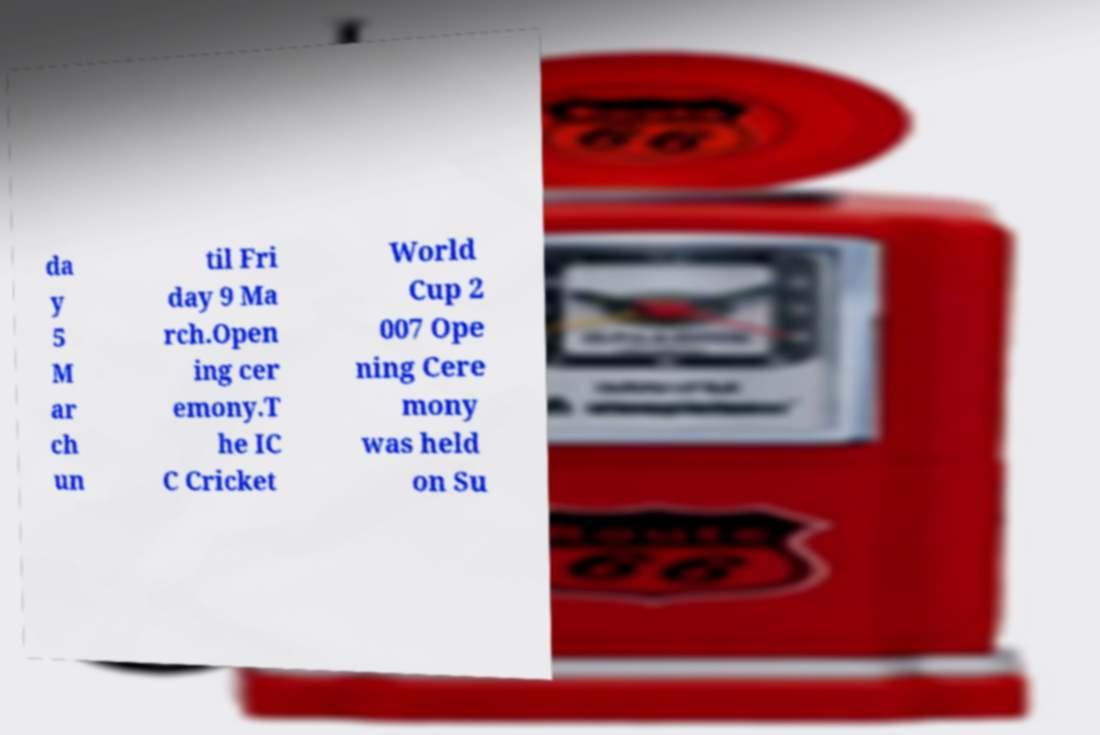Please identify and transcribe the text found in this image. da y 5 M ar ch un til Fri day 9 Ma rch.Open ing cer emony.T he IC C Cricket World Cup 2 007 Ope ning Cere mony was held on Su 